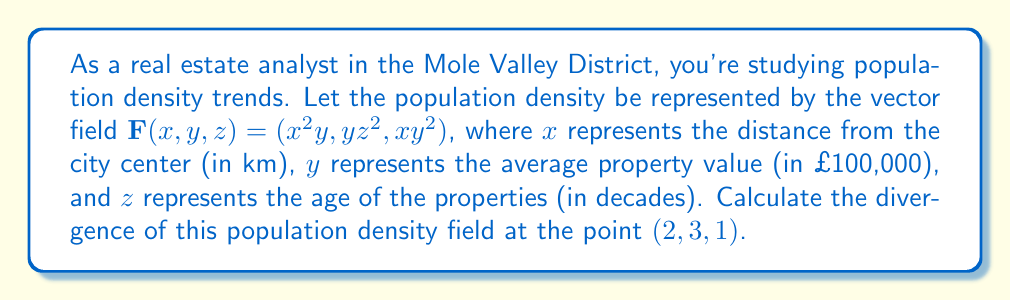Could you help me with this problem? To solve this problem, we need to follow these steps:

1) The divergence of a vector field $\mathbf{F}(x,y,z) = (F_1, F_2, F_3)$ is given by:

   $$\text{div}\mathbf{F} = \nabla \cdot \mathbf{F} = \frac{\partial F_1}{\partial x} + \frac{\partial F_2}{\partial y} + \frac{\partial F_3}{\partial z}$$

2) In our case:
   $F_1 = x^2y$
   $F_2 = yz^2$
   $F_3 = xy^2$

3) Let's calculate each partial derivative:

   $\frac{\partial F_1}{\partial x} = \frac{\partial}{\partial x}(x^2y) = 2xy$

   $\frac{\partial F_2}{\partial y} = \frac{\partial}{\partial y}(yz^2) = z^2$

   $\frac{\partial F_3}{\partial z} = \frac{\partial}{\partial z}(xy^2) = 0$

4) Now, we can sum these partial derivatives:

   $$\text{div}\mathbf{F} = 2xy + z^2 + 0 = 2xy + z^2$$

5) Finally, we evaluate this at the point $(2, 3, 1)$:

   $$\text{div}\mathbf{F}(2,3,1) = 2(2)(3) + 1^2 = 12 + 1 = 13$$

Therefore, the divergence of the population density field at the point (2, 3, 1) is 13.
Answer: 13 